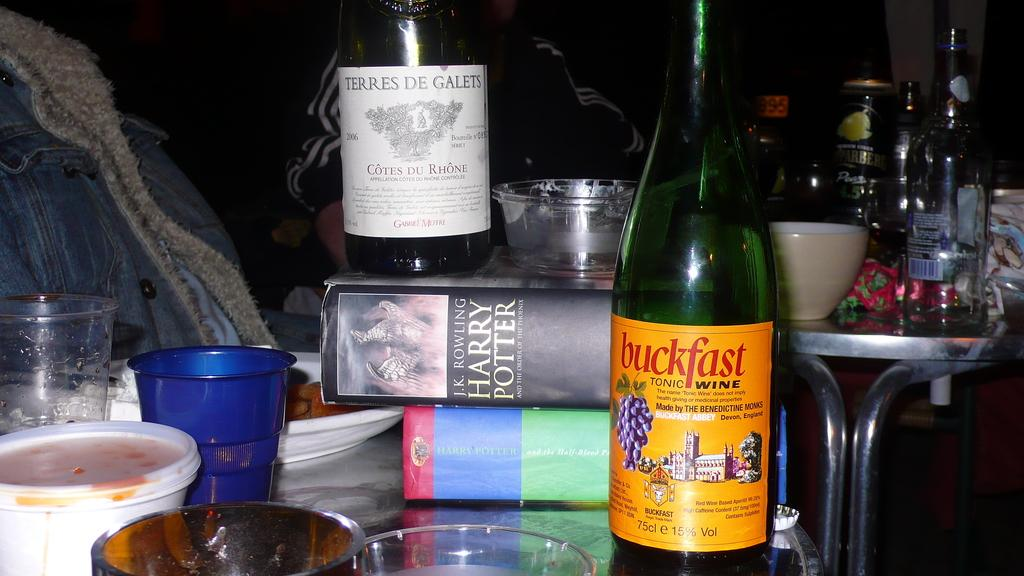Provide a one-sentence caption for the provided image. A Harry Potter book that is laying on its side. 